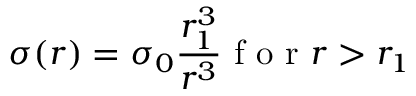<formula> <loc_0><loc_0><loc_500><loc_500>\sigma ( r ) = \sigma _ { 0 } \frac { r _ { 1 } ^ { 3 } } { r ^ { 3 } } f o r r > r _ { 1 }</formula> 